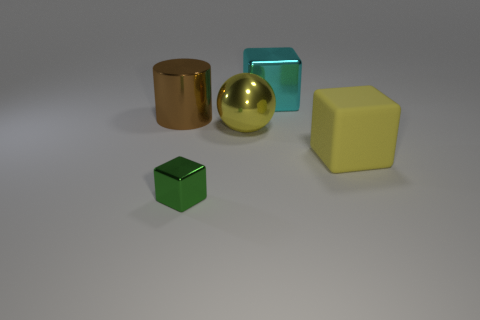Add 4 small blocks. How many objects exist? 9 Subtract all metal cubes. Subtract all blue matte things. How many objects are left? 3 Add 5 metallic cylinders. How many metallic cylinders are left? 6 Add 4 tiny blocks. How many tiny blocks exist? 5 Subtract 1 yellow cubes. How many objects are left? 4 Subtract all balls. How many objects are left? 4 